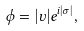Convert formula to latex. <formula><loc_0><loc_0><loc_500><loc_500>\phi = | \upsilon | e ^ { i | \sigma | } ,</formula> 